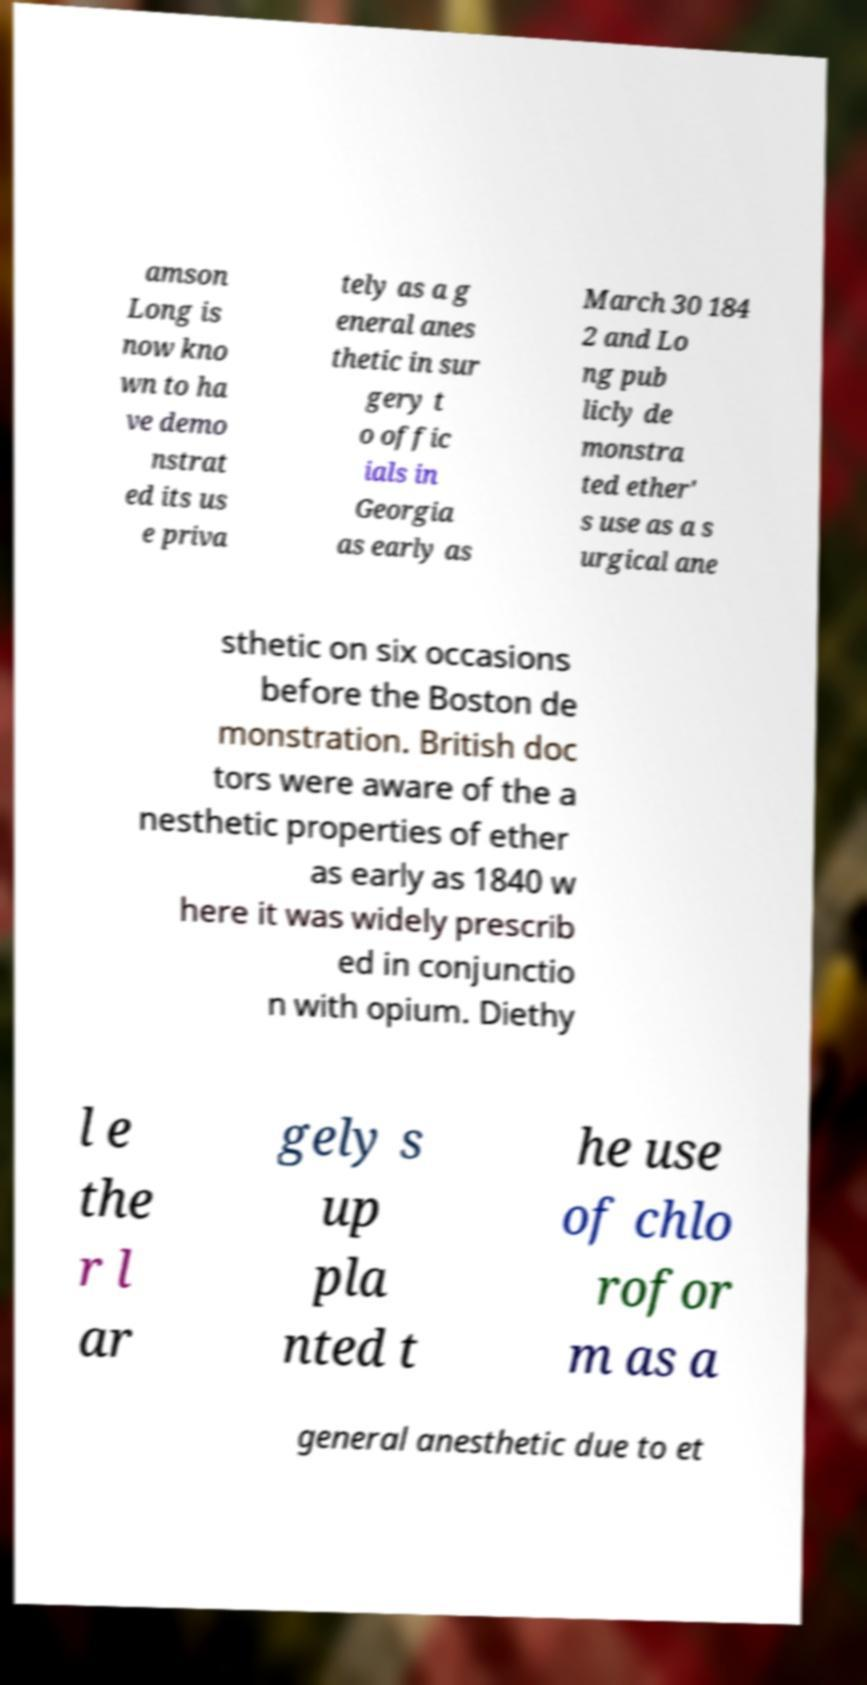Can you read and provide the text displayed in the image?This photo seems to have some interesting text. Can you extract and type it out for me? amson Long is now kno wn to ha ve demo nstrat ed its us e priva tely as a g eneral anes thetic in sur gery t o offic ials in Georgia as early as March 30 184 2 and Lo ng pub licly de monstra ted ether' s use as a s urgical ane sthetic on six occasions before the Boston de monstration. British doc tors were aware of the a nesthetic properties of ether as early as 1840 w here it was widely prescrib ed in conjunctio n with opium. Diethy l e the r l ar gely s up pla nted t he use of chlo rofor m as a general anesthetic due to et 